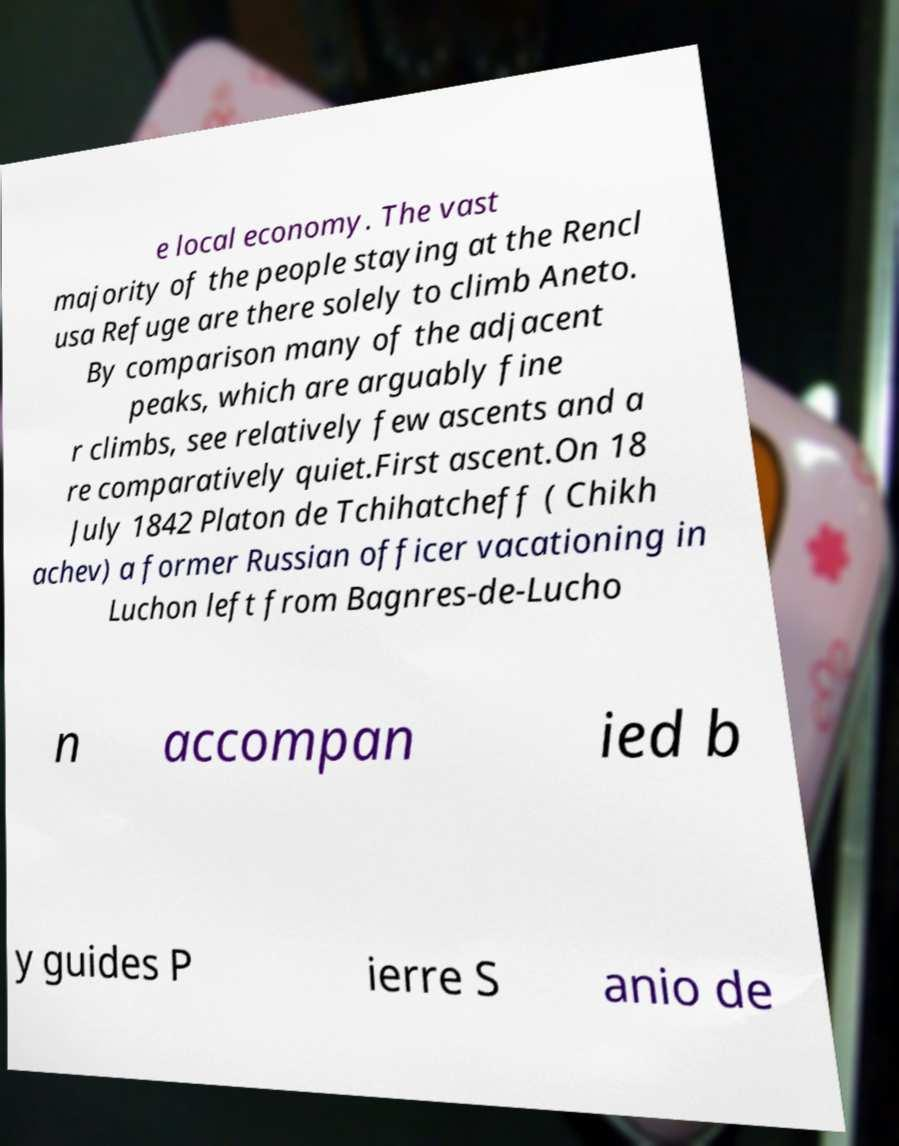I need the written content from this picture converted into text. Can you do that? e local economy. The vast majority of the people staying at the Rencl usa Refuge are there solely to climb Aneto. By comparison many of the adjacent peaks, which are arguably fine r climbs, see relatively few ascents and a re comparatively quiet.First ascent.On 18 July 1842 Platon de Tchihatcheff ( Chikh achev) a former Russian officer vacationing in Luchon left from Bagnres-de-Lucho n accompan ied b y guides P ierre S anio de 